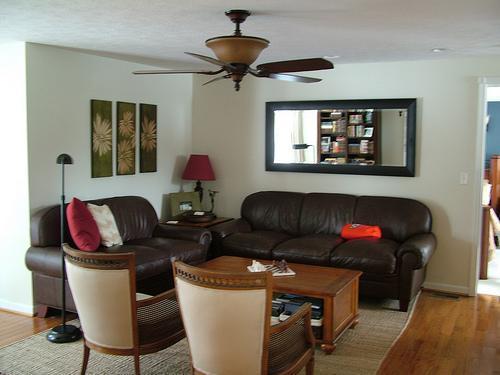How many chairs are there?
Give a very brief answer. 2. 